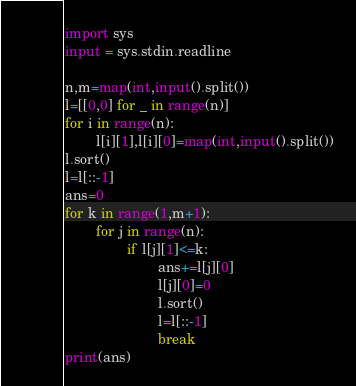Convert code to text. <code><loc_0><loc_0><loc_500><loc_500><_Python_>import sys
input = sys.stdin.readline

n,m=map(int,input().split())
l=[[0,0] for _ in range(n)]
for i in range(n):
        l[i][1],l[i][0]=map(int,input().split())
l.sort()
l=l[::-1]
ans=0
for k in range(1,m+1):
        for j in range(n):
                if l[j][1]<=k:
                        ans+=l[j][0]
                        l[j][0]=0
                        l.sort()
                        l=l[::-1]
                        break
print(ans)</code> 